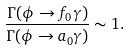Convert formula to latex. <formula><loc_0><loc_0><loc_500><loc_500>\frac { \Gamma ( \phi \to f _ { 0 } \gamma ) } { \Gamma ( \phi \to a _ { 0 } \gamma ) } \sim 1 .</formula> 